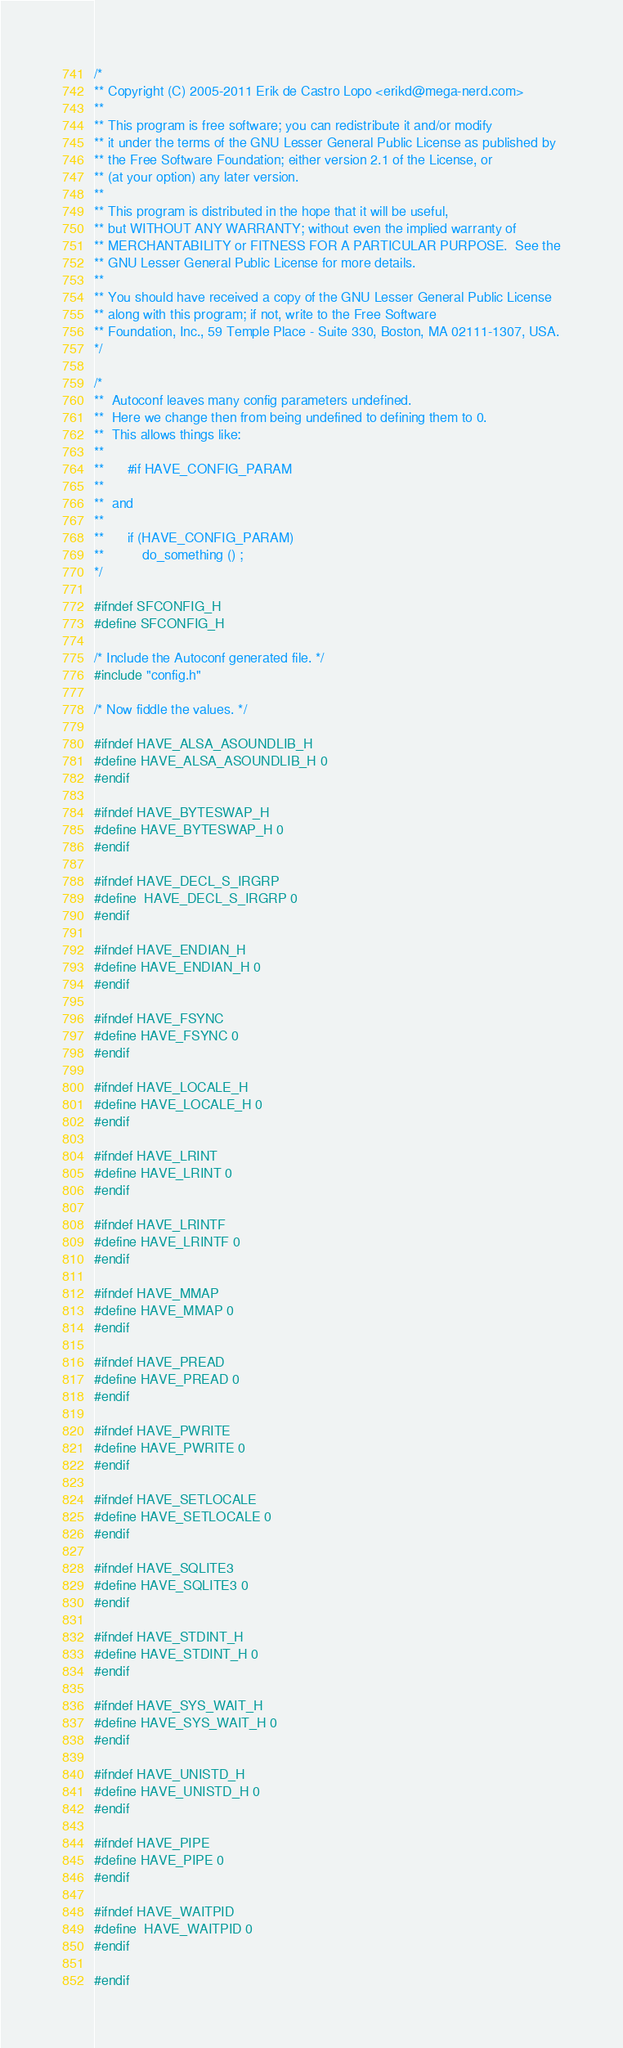<code> <loc_0><loc_0><loc_500><loc_500><_C_>/*
** Copyright (C) 2005-2011 Erik de Castro Lopo <erikd@mega-nerd.com>
**
** This program is free software; you can redistribute it and/or modify
** it under the terms of the GNU Lesser General Public License as published by
** the Free Software Foundation; either version 2.1 of the License, or
** (at your option) any later version.
**
** This program is distributed in the hope that it will be useful,
** but WITHOUT ANY WARRANTY; without even the implied warranty of
** MERCHANTABILITY or FITNESS FOR A PARTICULAR PURPOSE.  See the
** GNU Lesser General Public License for more details.
**
** You should have received a copy of the GNU Lesser General Public License
** along with this program; if not, write to the Free Software
** Foundation, Inc., 59 Temple Place - Suite 330, Boston, MA 02111-1307, USA.
*/

/*
**	Autoconf leaves many config parameters undefined.
**	Here we change then from being undefined to defining them to 0.
**	This allows things like:
**
**		#if HAVE_CONFIG_PARAM
**
**	and
**
**		if (HAVE_CONFIG_PARAM)
**			do_something () ;
*/

#ifndef SFCONFIG_H
#define SFCONFIG_H

/* Include the Autoconf generated file. */
#include "config.h"

/* Now fiddle the values. */

#ifndef HAVE_ALSA_ASOUNDLIB_H
#define HAVE_ALSA_ASOUNDLIB_H 0
#endif

#ifndef HAVE_BYTESWAP_H
#define HAVE_BYTESWAP_H 0
#endif

#ifndef HAVE_DECL_S_IRGRP
#define	HAVE_DECL_S_IRGRP 0
#endif

#ifndef HAVE_ENDIAN_H
#define HAVE_ENDIAN_H 0
#endif

#ifndef HAVE_FSYNC
#define HAVE_FSYNC 0
#endif

#ifndef HAVE_LOCALE_H
#define HAVE_LOCALE_H 0
#endif

#ifndef HAVE_LRINT
#define HAVE_LRINT 0
#endif

#ifndef HAVE_LRINTF
#define HAVE_LRINTF 0
#endif

#ifndef HAVE_MMAP
#define HAVE_MMAP 0
#endif

#ifndef HAVE_PREAD
#define HAVE_PREAD 0
#endif

#ifndef HAVE_PWRITE
#define HAVE_PWRITE 0
#endif

#ifndef HAVE_SETLOCALE
#define HAVE_SETLOCALE 0
#endif

#ifndef HAVE_SQLITE3
#define HAVE_SQLITE3 0
#endif

#ifndef HAVE_STDINT_H
#define HAVE_STDINT_H 0
#endif

#ifndef HAVE_SYS_WAIT_H
#define HAVE_SYS_WAIT_H 0
#endif

#ifndef HAVE_UNISTD_H
#define HAVE_UNISTD_H 0
#endif

#ifndef HAVE_PIPE
#define HAVE_PIPE 0
#endif

#ifndef HAVE_WAITPID
#define	HAVE_WAITPID 0
#endif

#endif

</code> 